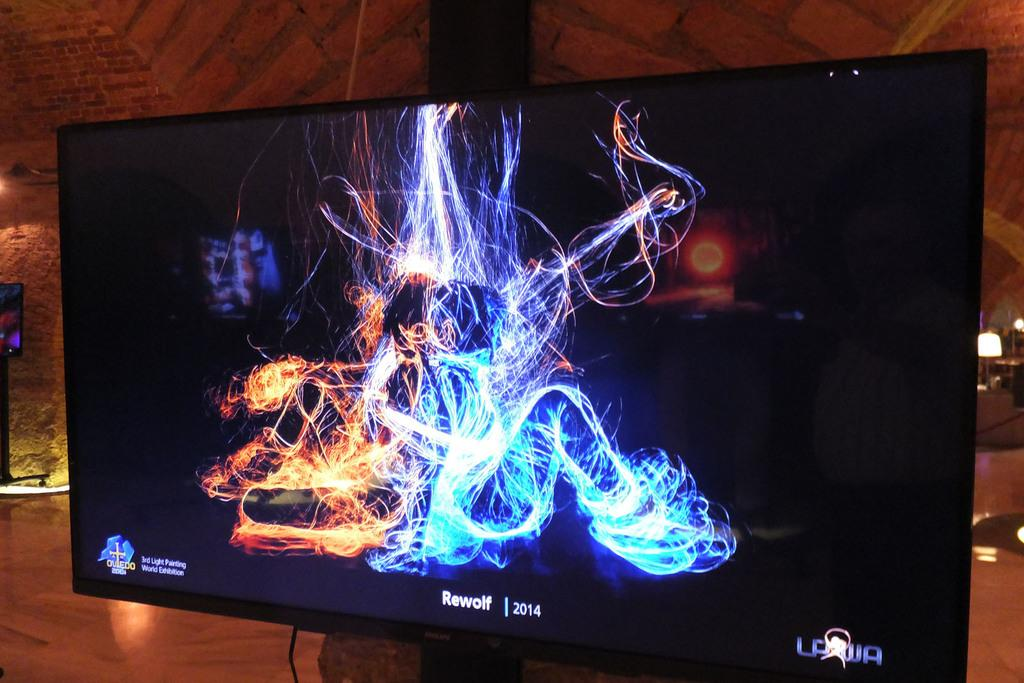<image>
Share a concise interpretation of the image provided. Rewolf 2014 is written on a screen below an electric picture. 